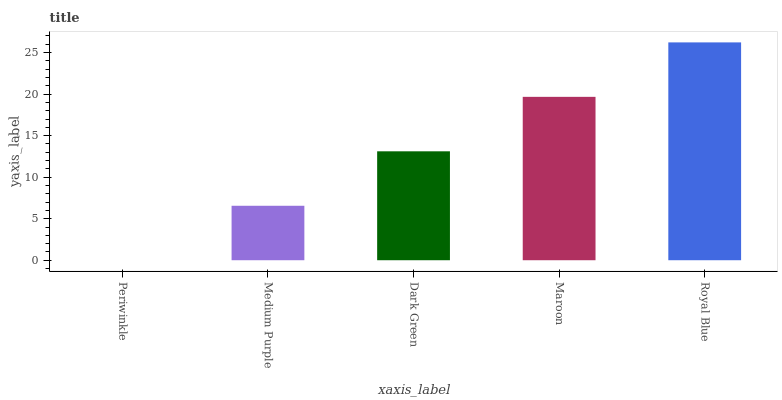Is Periwinkle the minimum?
Answer yes or no. Yes. Is Royal Blue the maximum?
Answer yes or no. Yes. Is Medium Purple the minimum?
Answer yes or no. No. Is Medium Purple the maximum?
Answer yes or no. No. Is Medium Purple greater than Periwinkle?
Answer yes or no. Yes. Is Periwinkle less than Medium Purple?
Answer yes or no. Yes. Is Periwinkle greater than Medium Purple?
Answer yes or no. No. Is Medium Purple less than Periwinkle?
Answer yes or no. No. Is Dark Green the high median?
Answer yes or no. Yes. Is Dark Green the low median?
Answer yes or no. Yes. Is Periwinkle the high median?
Answer yes or no. No. Is Royal Blue the low median?
Answer yes or no. No. 